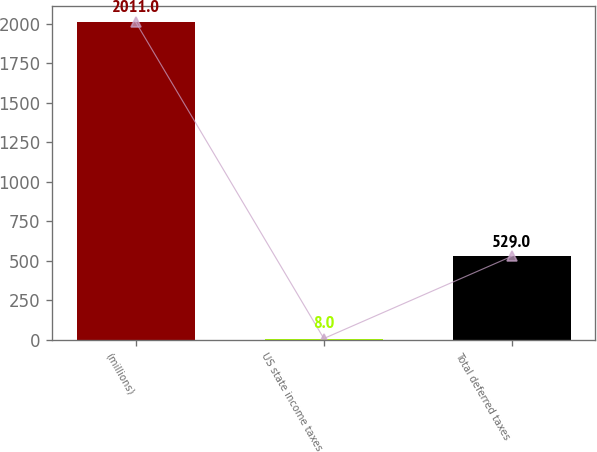Convert chart. <chart><loc_0><loc_0><loc_500><loc_500><bar_chart><fcel>(millions)<fcel>US state income taxes<fcel>Total deferred taxes<nl><fcel>2011<fcel>8<fcel>529<nl></chart> 